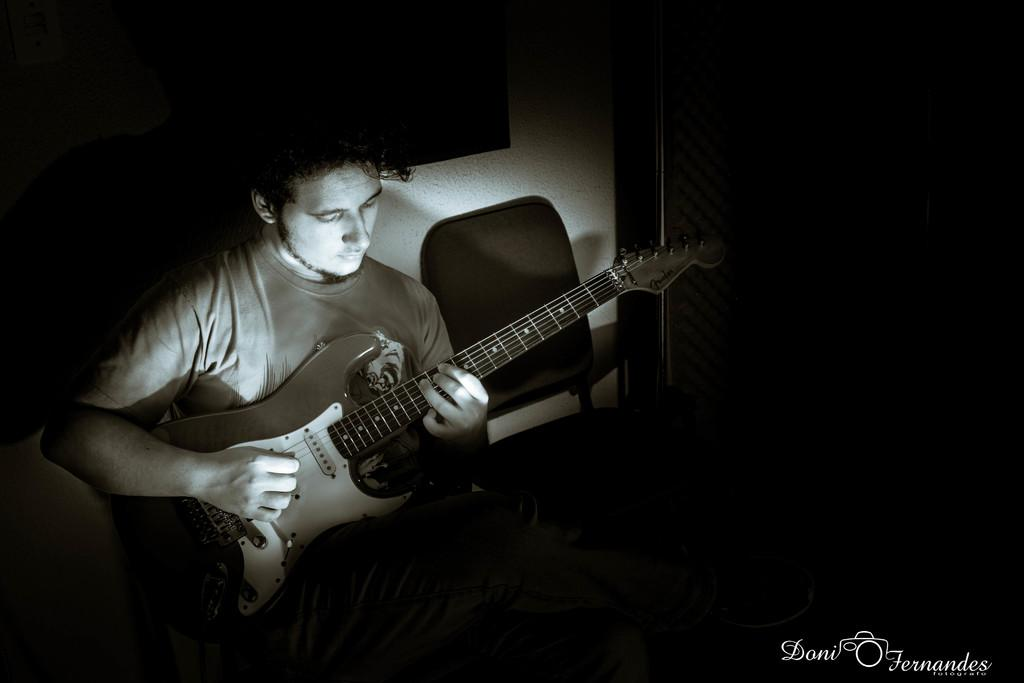What is the person in the image doing? The person is holding a guitar. What is the person sitting on in the image? The person is sitting on a chair. Where can you find text written on the image? The text is written in the right side corner of the image. What type of rod is the person using to play the guitar in the image? There is no rod visible in the image; the person is using their hands to play the guitar. 